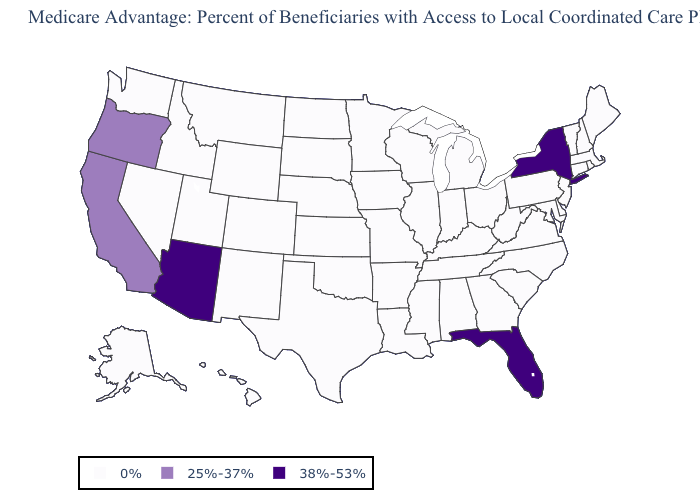Name the states that have a value in the range 38%-53%?
Keep it brief. Arizona, Florida, New York. Among the states that border Nebraska , which have the lowest value?
Concise answer only. Colorado, Iowa, Kansas, Missouri, South Dakota, Wyoming. What is the value of Oklahoma?
Keep it brief. 0%. Does Washington have a lower value than California?
Be succinct. Yes. What is the lowest value in states that border Oregon?
Be succinct. 0%. What is the value of Vermont?
Answer briefly. 0%. Name the states that have a value in the range 0%?
Write a very short answer. Alaska, Alabama, Arkansas, Colorado, Connecticut, Delaware, Georgia, Hawaii, Iowa, Idaho, Illinois, Indiana, Kansas, Kentucky, Louisiana, Massachusetts, Maryland, Maine, Michigan, Minnesota, Missouri, Mississippi, Montana, North Carolina, North Dakota, Nebraska, New Hampshire, New Jersey, New Mexico, Nevada, Ohio, Oklahoma, Pennsylvania, Rhode Island, South Carolina, South Dakota, Tennessee, Texas, Utah, Virginia, Vermont, Washington, Wisconsin, West Virginia, Wyoming. Name the states that have a value in the range 25%-37%?
Concise answer only. California, Oregon. What is the highest value in the USA?
Keep it brief. 38%-53%. Name the states that have a value in the range 0%?
Write a very short answer. Alaska, Alabama, Arkansas, Colorado, Connecticut, Delaware, Georgia, Hawaii, Iowa, Idaho, Illinois, Indiana, Kansas, Kentucky, Louisiana, Massachusetts, Maryland, Maine, Michigan, Minnesota, Missouri, Mississippi, Montana, North Carolina, North Dakota, Nebraska, New Hampshire, New Jersey, New Mexico, Nevada, Ohio, Oklahoma, Pennsylvania, Rhode Island, South Carolina, South Dakota, Tennessee, Texas, Utah, Virginia, Vermont, Washington, Wisconsin, West Virginia, Wyoming. Which states have the lowest value in the USA?
Concise answer only. Alaska, Alabama, Arkansas, Colorado, Connecticut, Delaware, Georgia, Hawaii, Iowa, Idaho, Illinois, Indiana, Kansas, Kentucky, Louisiana, Massachusetts, Maryland, Maine, Michigan, Minnesota, Missouri, Mississippi, Montana, North Carolina, North Dakota, Nebraska, New Hampshire, New Jersey, New Mexico, Nevada, Ohio, Oklahoma, Pennsylvania, Rhode Island, South Carolina, South Dakota, Tennessee, Texas, Utah, Virginia, Vermont, Washington, Wisconsin, West Virginia, Wyoming. What is the value of South Carolina?
Answer briefly. 0%. 